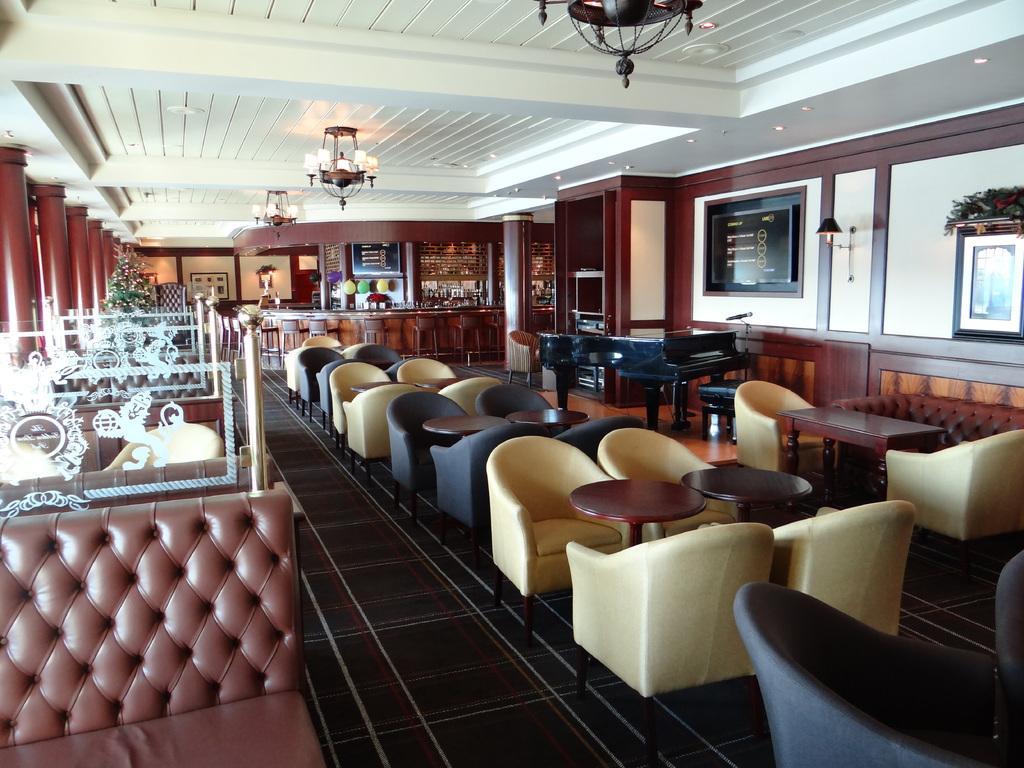Could you give a brief overview of what you see in this image? In the image we can see there are tables and chairs kept in the room, beside there is a piano and there are sofa at the corner. Behind there is a reception and there are photo frames on the wall. There are lighting and chandelier on the top and there is a christmas tree at the back. 